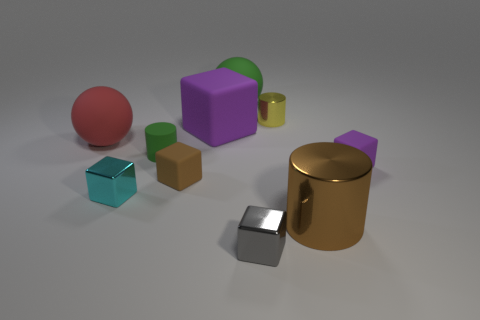The other cube that is the same color as the large cube is what size?
Provide a succinct answer. Small. Is the large rubber cube the same color as the small rubber cylinder?
Ensure brevity in your answer.  No. Are there any other things that are the same size as the brown matte object?
Your answer should be compact. Yes. What shape is the purple rubber object in front of the red matte object in front of the yellow metallic thing?
Offer a very short reply. Cube. Are there fewer large yellow rubber cubes than big shiny things?
Your response must be concise. Yes. What is the size of the object that is both to the right of the gray metallic object and behind the large purple block?
Provide a short and direct response. Small. Is the size of the cyan metallic cube the same as the yellow object?
Give a very brief answer. Yes. Does the block that is behind the tiny green cylinder have the same color as the big metal thing?
Ensure brevity in your answer.  No. There is a red matte object; how many matte spheres are right of it?
Give a very brief answer. 1. Are there more big matte spheres than tiny yellow things?
Provide a succinct answer. Yes. 